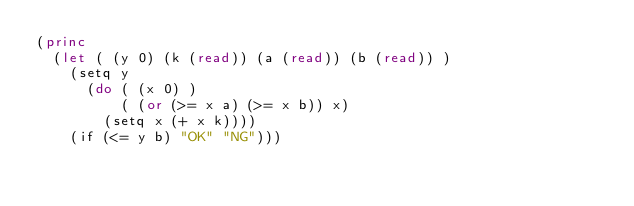<code> <loc_0><loc_0><loc_500><loc_500><_Lisp_>(princ 
  (let ( (y 0) (k (read)) (a (read)) (b (read)) )
    (setq y 
      (do ( (x 0) ) 
          ( (or (>= x a) (>= x b)) x) 
        (setq x (+ x k)))) 
    (if (<= y b) "OK" "NG")))
</code> 